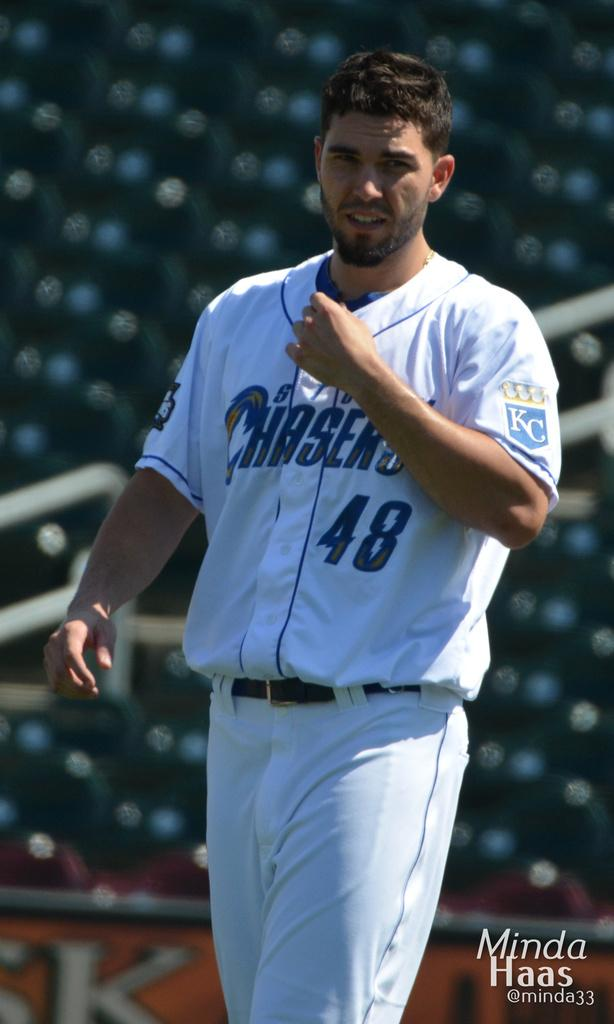<image>
Create a compact narrative representing the image presented. a baseball player with a 48 jersey walks around a field 